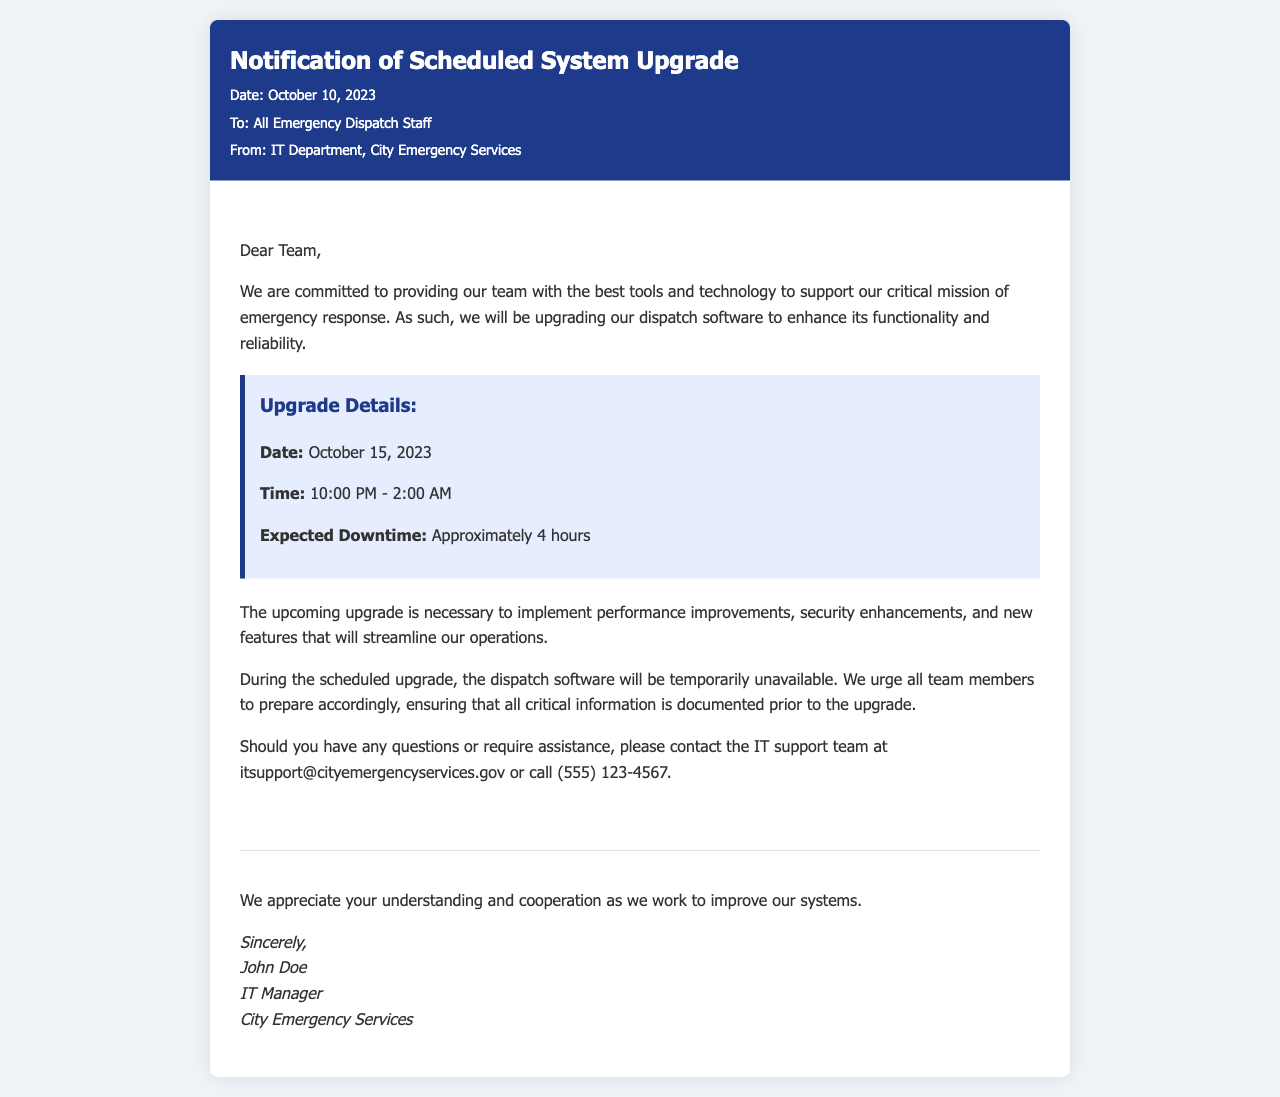What is the date of the scheduled upgrade? The date of the scheduled upgrade is mentioned in the upgrade details section.
Answer: October 15, 2023 What time will the upgrade start? The start time of the upgrade is provided in the upgrade details section.
Answer: 10:00 PM What is the expected downtime for the software? The expected downtime is explicitly stated in the upgrade details section.
Answer: Approximately 4 hours Who is the sender of the notification? The sender's name and title are mentioned in the footer of the document.
Answer: John Doe What should team members ensure before the upgrade? The document advises on a specific action to take before the upgrade in order to prepare adequately.
Answer: All critical information is documented What is the purpose of the upgrade? The purpose of the upgrade is mentioned in the introduction of the content section.
Answer: To implement performance improvements, security enhancements, and new features What department is responsible for the upgrade communication? The department responsible is identified in the heading of the document.
Answer: IT Department What is the contact email for IT support? The email address for IT support is specified in the content section.
Answer: itsupport@cityemergencyservices.gov 